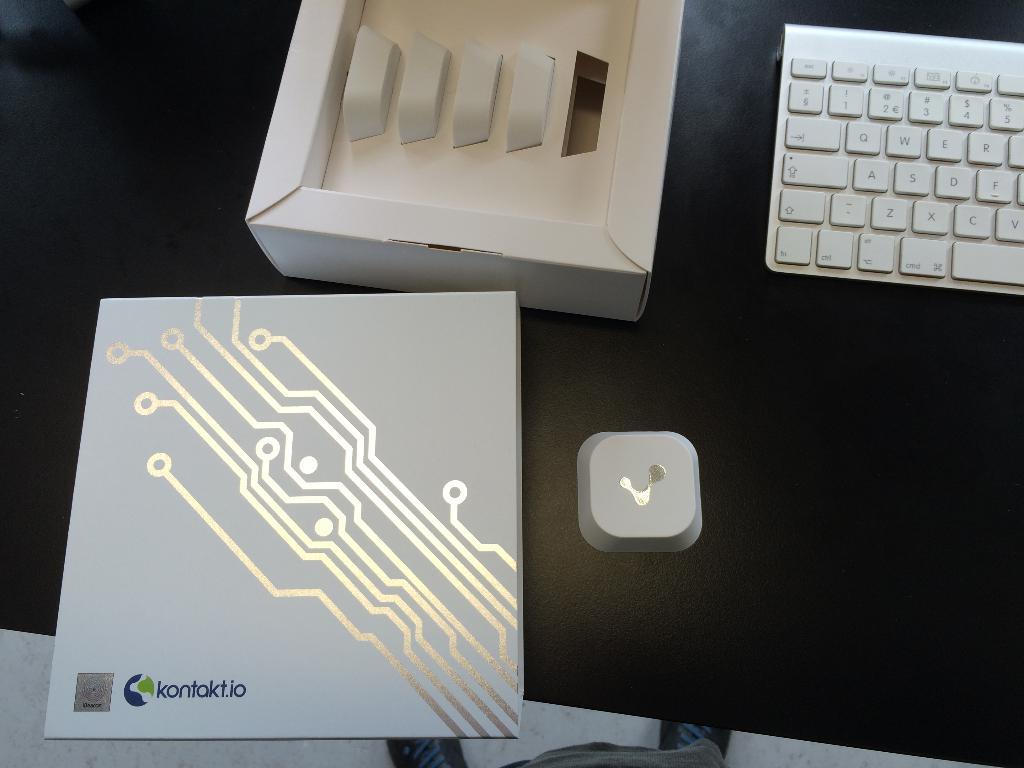What's the web address on the book?
Offer a very short reply. Kontakt.io. 